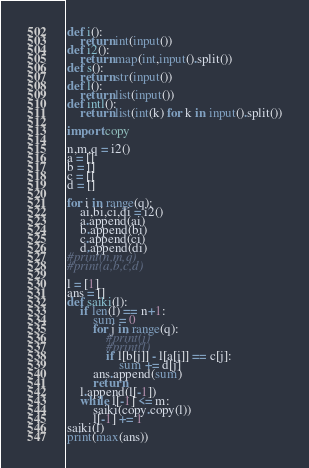Convert code to text. <code><loc_0><loc_0><loc_500><loc_500><_Python_>def i():
	return int(input())
def i2():
	return map(int,input().split())
def s():
	return str(input())
def l():
	return list(input())
def intl():
	return list(int(k) for k in input().split())

import copy

n,m,q = i2()
a = []
b = []
c = []
d = []

for i in range(q):
	ai,bi,ci,di = i2()
	a.append(ai)
	b.append(bi)
	c.append(ci)
	d.append(di)
#print(n,m,q)
#print(a,b,c,d)

l = [1]
ans = []
def saiki(l):
	if len(l) == n+1:
		sum = 0
		for j in range(q):
			#print(j)
			#print(l)
			if l[b[j]] - l[a[j]] == c[j]:
				sum += d[j]
		ans.append(sum)
		return
	l.append(l[-1])
	while l[-1] <= m:
		saiki(copy.copy(l))
		l[-1] += 1
saiki(l)
print(max(ans))</code> 